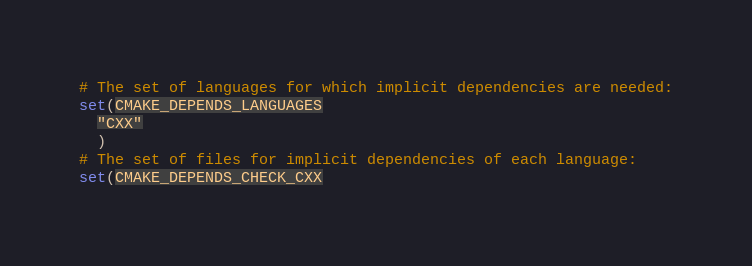Convert code to text. <code><loc_0><loc_0><loc_500><loc_500><_CMake_># The set of languages for which implicit dependencies are needed:
set(CMAKE_DEPENDS_LANGUAGES
  "CXX"
  )
# The set of files for implicit dependencies of each language:
set(CMAKE_DEPENDS_CHECK_CXX</code> 